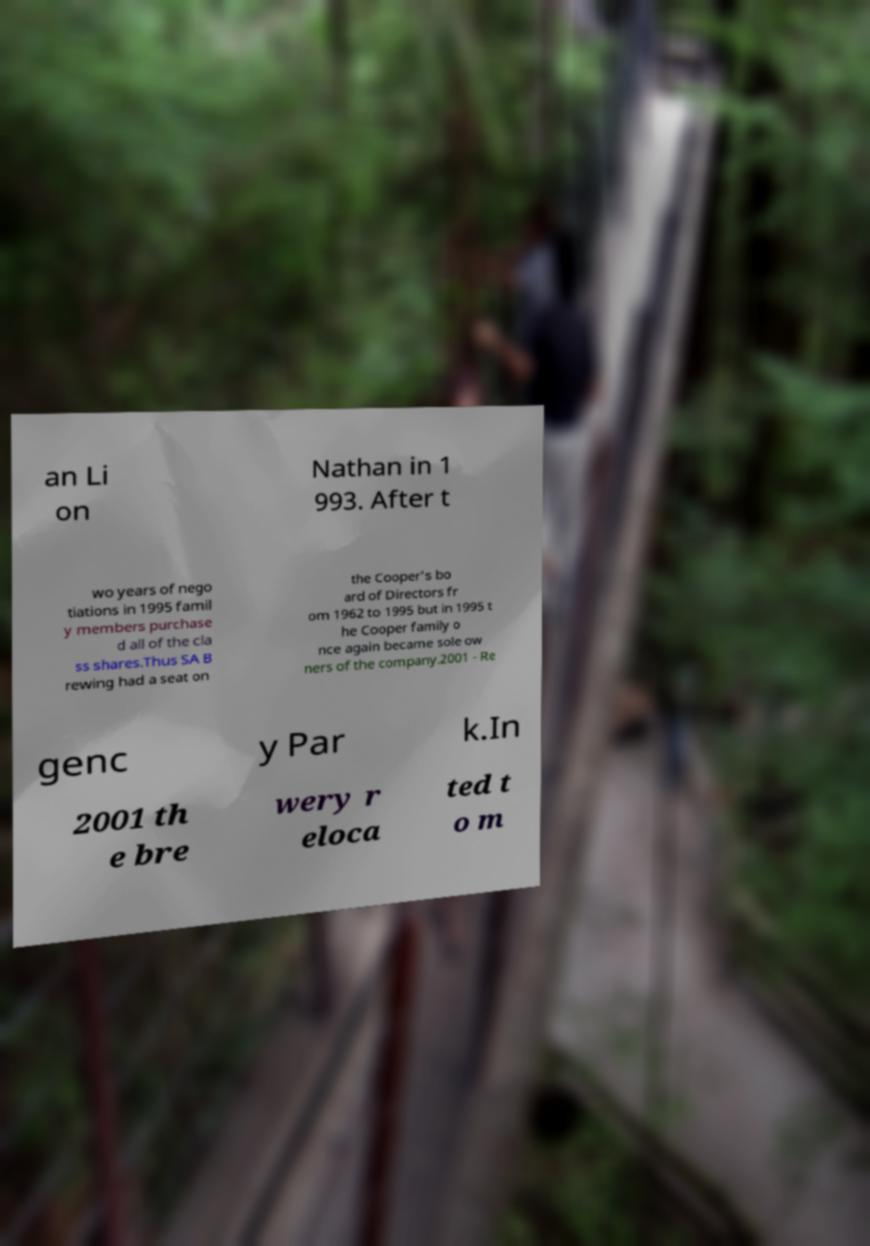I need the written content from this picture converted into text. Can you do that? an Li on Nathan in 1 993. After t wo years of nego tiations in 1995 famil y members purchase d all of the cla ss shares.Thus SA B rewing had a seat on the Cooper's bo ard of Directors fr om 1962 to 1995 but in 1995 t he Cooper family o nce again became sole ow ners of the company.2001 - Re genc y Par k.In 2001 th e bre wery r eloca ted t o m 